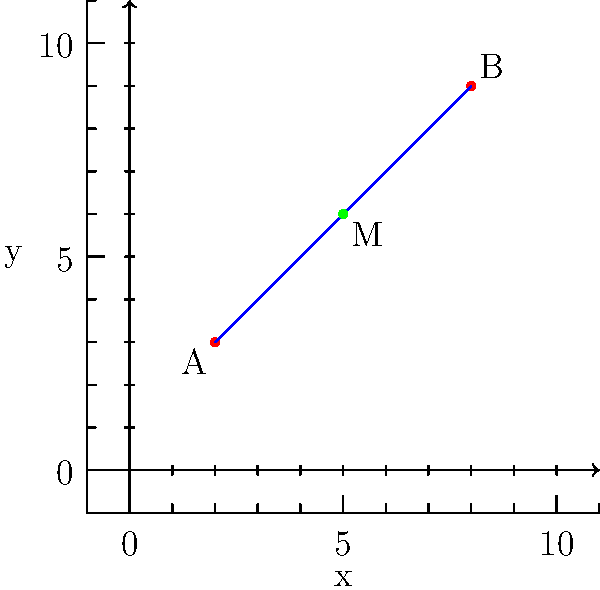Hey Arlene, remember our Coordinate Geometry class at Columbia? Let's test our skills! Given two points A(2,3) and B(8,9) on a line segment, find the coordinates of the midpoint M. To find the midpoint of a line segment, we can use the midpoint formula:

$$M = (\frac{x_1 + x_2}{2}, \frac{y_1 + y_2}{2})$$

where $(x_1, y_1)$ and $(x_2, y_2)$ are the coordinates of the endpoints.

Step 1: Identify the coordinates of the endpoints
A(2,3) and B(8,9)
So, $x_1 = 2$, $y_1 = 3$, $x_2 = 8$, and $y_2 = 9$

Step 2: Apply the midpoint formula for the x-coordinate
$$x_M = \frac{x_1 + x_2}{2} = \frac{2 + 8}{2} = \frac{10}{2} = 5$$

Step 3: Apply the midpoint formula for the y-coordinate
$$y_M = \frac{y_1 + y_2}{2} = \frac{3 + 9}{2} = \frac{12}{2} = 6$$

Step 4: Combine the results to get the midpoint coordinates
The midpoint M has coordinates (5,6)
Answer: (5,6) 